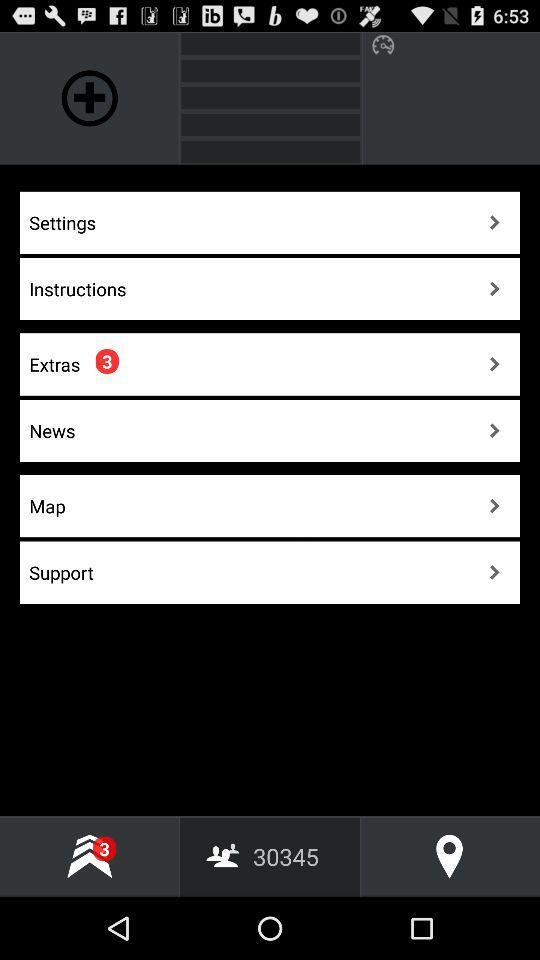How many pending notifications are there in extras? There are 3 pending notifications in the extras. 